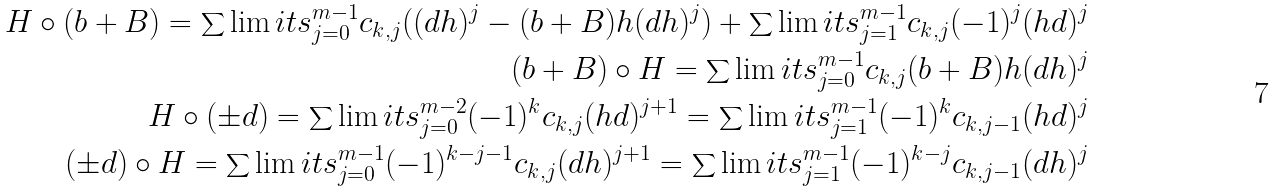Convert formula to latex. <formula><loc_0><loc_0><loc_500><loc_500>H \circ ( b + B ) = \sum \lim i t s _ { j = 0 } ^ { m - 1 } c _ { k , j } ( ( d h ) ^ { j } - ( b + B ) h ( d h ) ^ { j } ) + \sum \lim i t s _ { j = 1 } ^ { m - 1 } c _ { k , j } ( - 1 ) ^ { j } ( h d ) ^ { j } \\ ( b + B ) \circ H = \sum \lim i t s _ { j = 0 } ^ { m - 1 } c _ { k , j } ( b + B ) h ( d h ) ^ { j } \\ H \circ ( \pm d ) = \sum \lim i t s _ { j = 0 } ^ { m - 2 } ( - 1 ) ^ { k } c _ { k , j } ( h d ) ^ { j + 1 } = \sum \lim i t s _ { j = 1 } ^ { m - 1 } ( - 1 ) ^ { k } c _ { k , j - 1 } ( h d ) ^ { j } \\ ( \pm d ) \circ H = \sum \lim i t s _ { j = 0 } ^ { m - 1 } ( - 1 ) ^ { k - j - 1 } c _ { k , j } ( d h ) ^ { j + 1 } = \sum \lim i t s _ { j = 1 } ^ { m - 1 } ( - 1 ) ^ { k - j } c _ { k , j - 1 } ( d h ) ^ { j }</formula> 